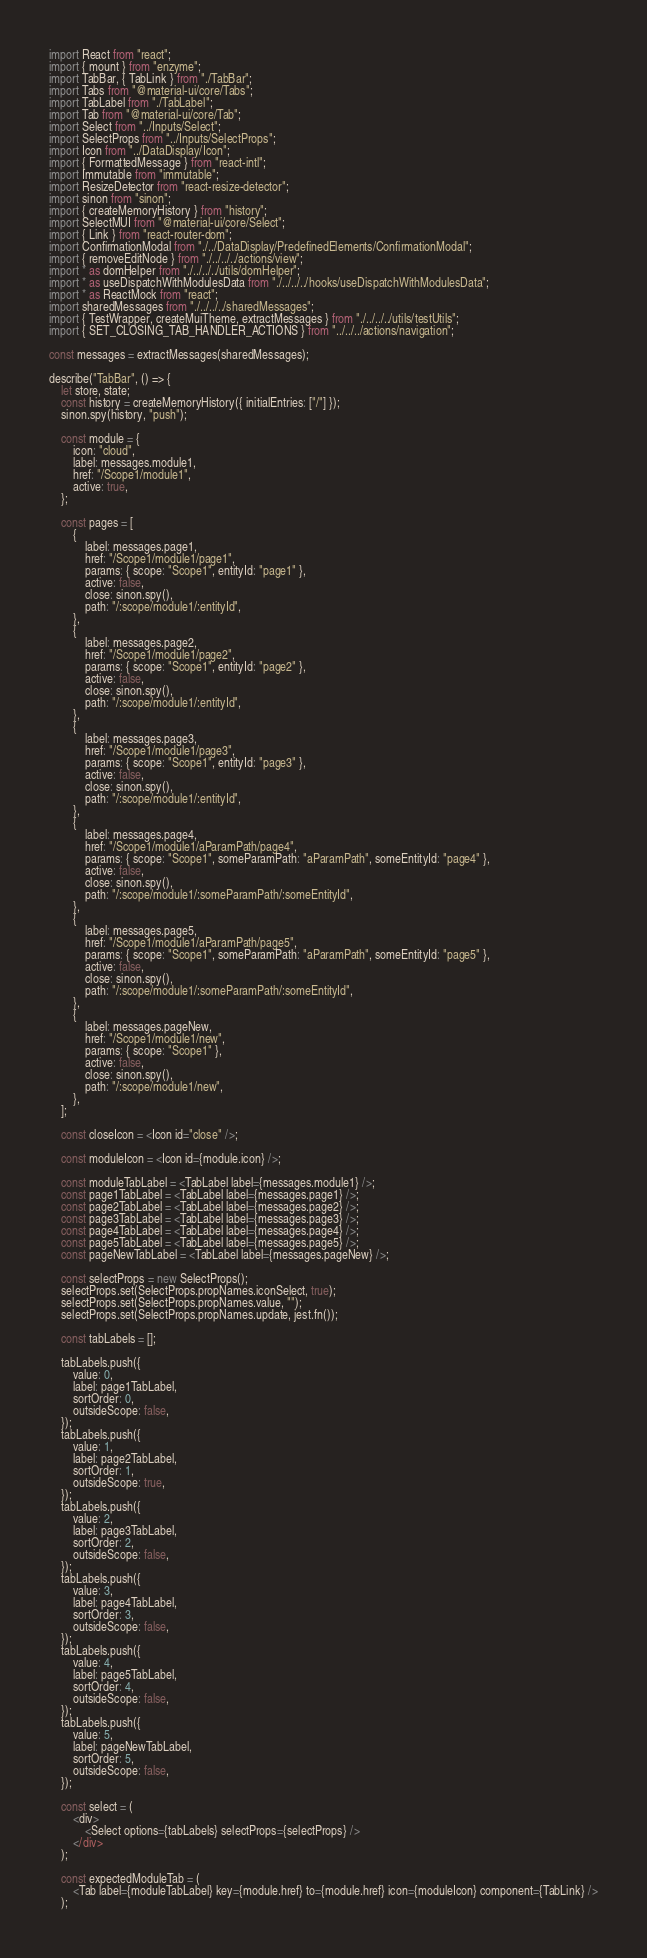<code> <loc_0><loc_0><loc_500><loc_500><_JavaScript_>import React from "react";
import { mount } from "enzyme";
import TabBar, { TabLink } from "./TabBar";
import Tabs from "@material-ui/core/Tabs";
import TabLabel from "./TabLabel";
import Tab from "@material-ui/core/Tab";
import Select from "../Inputs/Select";
import SelectProps from "../Inputs/SelectProps";
import Icon from "../DataDisplay/Icon";
import { FormattedMessage } from "react-intl";
import Immutable from "immutable";
import ResizeDetector from "react-resize-detector";
import sinon from "sinon";
import { createMemoryHistory } from "history";
import SelectMUI from "@material-ui/core/Select";
import { Link } from "react-router-dom";
import ConfirmationModal from "./../DataDisplay/PredefinedElements/ConfirmationModal";
import { removeEditNode } from "./../../../actions/view";
import * as domHelper from "./../../../utils/domHelper";
import * as useDispatchWithModulesData from "./../../../hooks/useDispatchWithModulesData";
import * as ReactMock from "react";
import sharedMessages from "./../../../sharedMessages";
import { TestWrapper, createMuiTheme, extractMessages } from "./../../../utils/testUtils";
import { SET_CLOSING_TAB_HANDLER_ACTIONS } from "../../../actions/navigation";

const messages = extractMessages(sharedMessages);

describe("TabBar", () => {
	let store, state;
	const history = createMemoryHistory({ initialEntries: ["/"] });
	sinon.spy(history, "push");

	const module = {
		icon: "cloud",
		label: messages.module1,
		href: "/Scope1/module1",
		active: true,
	};

	const pages = [
		{
			label: messages.page1,
			href: "/Scope1/module1/page1",
			params: { scope: "Scope1", entityId: "page1" },
			active: false,
			close: sinon.spy(),
			path: "/:scope/module1/:entityId",
		},
		{
			label: messages.page2,
			href: "/Scope1/module1/page2",
			params: { scope: "Scope1", entityId: "page2" },
			active: false,
			close: sinon.spy(),
			path: "/:scope/module1/:entityId",
		},
		{
			label: messages.page3,
			href: "/Scope1/module1/page3",
			params: { scope: "Scope1", entityId: "page3" },
			active: false,
			close: sinon.spy(),
			path: "/:scope/module1/:entityId",
		},
		{
			label: messages.page4,
			href: "/Scope1/module1/aParamPath/page4",
			params: { scope: "Scope1", someParamPath: "aParamPath", someEntityId: "page4" },
			active: false,
			close: sinon.spy(),
			path: "/:scope/module1/:someParamPath/:someEntityId",
		},
		{
			label: messages.page5,
			href: "/Scope1/module1/aParamPath/page5",
			params: { scope: "Scope1", someParamPath: "aParamPath", someEntityId: "page5" },
			active: false,
			close: sinon.spy(),
			path: "/:scope/module1/:someParamPath/:someEntityId",
		},
		{
			label: messages.pageNew,
			href: "/Scope1/module1/new",
			params: { scope: "Scope1" },
			active: false,
			close: sinon.spy(),
			path: "/:scope/module1/new",
		},
	];

	const closeIcon = <Icon id="close" />;

	const moduleIcon = <Icon id={module.icon} />;

	const moduleTabLabel = <TabLabel label={messages.module1} />;
	const page1TabLabel = <TabLabel label={messages.page1} />;
	const page2TabLabel = <TabLabel label={messages.page2} />;
	const page3TabLabel = <TabLabel label={messages.page3} />;
	const page4TabLabel = <TabLabel label={messages.page4} />;
	const page5TabLabel = <TabLabel label={messages.page5} />;
	const pageNewTabLabel = <TabLabel label={messages.pageNew} />;

	const selectProps = new SelectProps();
	selectProps.set(SelectProps.propNames.iconSelect, true);
	selectProps.set(SelectProps.propNames.value, "");
	selectProps.set(SelectProps.propNames.update, jest.fn());

	const tabLabels = [];

	tabLabels.push({
		value: 0,
		label: page1TabLabel,
		sortOrder: 0,
		outsideScope: false,
	});
	tabLabels.push({
		value: 1,
		label: page2TabLabel,
		sortOrder: 1,
		outsideScope: true,
	});
	tabLabels.push({
		value: 2,
		label: page3TabLabel,
		sortOrder: 2,
		outsideScope: false,
	});
	tabLabels.push({
		value: 3,
		label: page4TabLabel,
		sortOrder: 3,
		outsideScope: false,
	});
	tabLabels.push({
		value: 4,
		label: page5TabLabel,
		sortOrder: 4,
		outsideScope: false,
	});
	tabLabels.push({
		value: 5,
		label: pageNewTabLabel,
		sortOrder: 5,
		outsideScope: false,
	});

	const select = (
		<div>
			<Select options={tabLabels} selectProps={selectProps} />
		</div>
	);

	const expectedModuleTab = (
		<Tab label={moduleTabLabel} key={module.href} to={module.href} icon={moduleIcon} component={TabLink} />
	);
</code> 